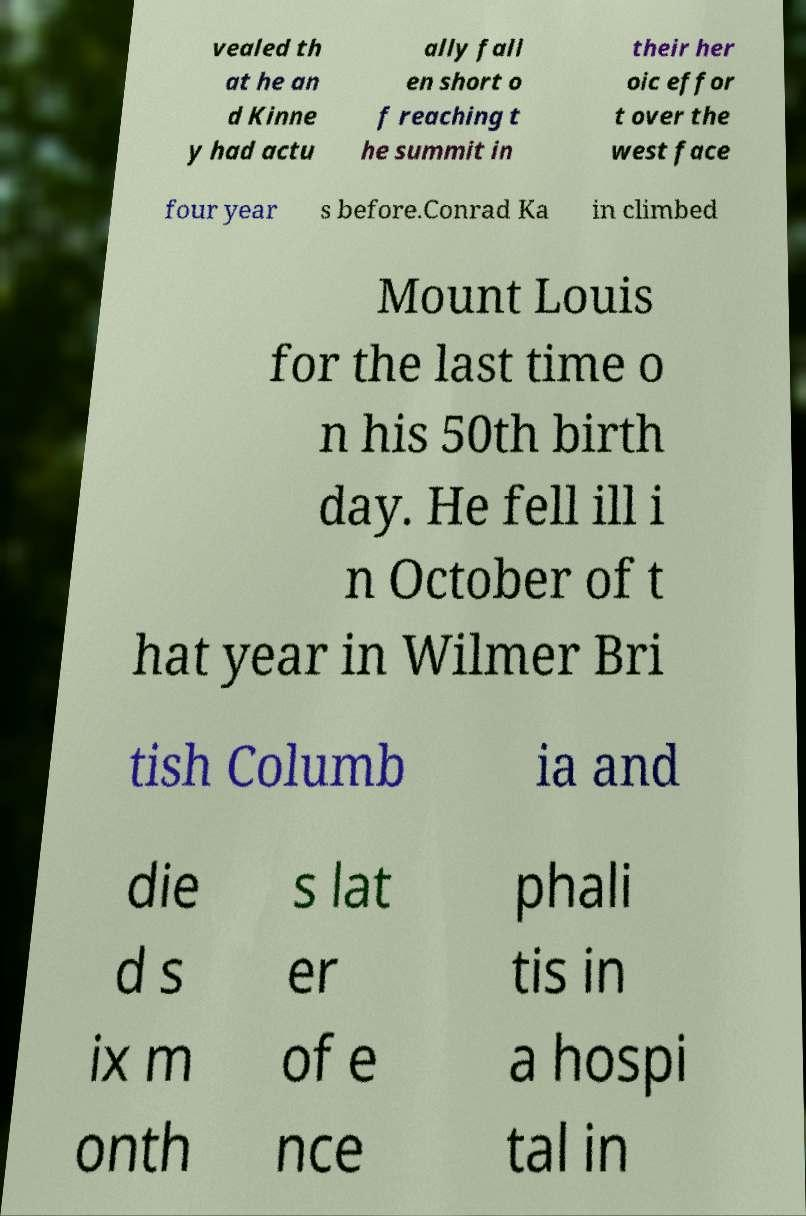Please identify and transcribe the text found in this image. vealed th at he an d Kinne y had actu ally fall en short o f reaching t he summit in their her oic effor t over the west face four year s before.Conrad Ka in climbed Mount Louis for the last time o n his 50th birth day. He fell ill i n October of t hat year in Wilmer Bri tish Columb ia and die d s ix m onth s lat er of e nce phali tis in a hospi tal in 